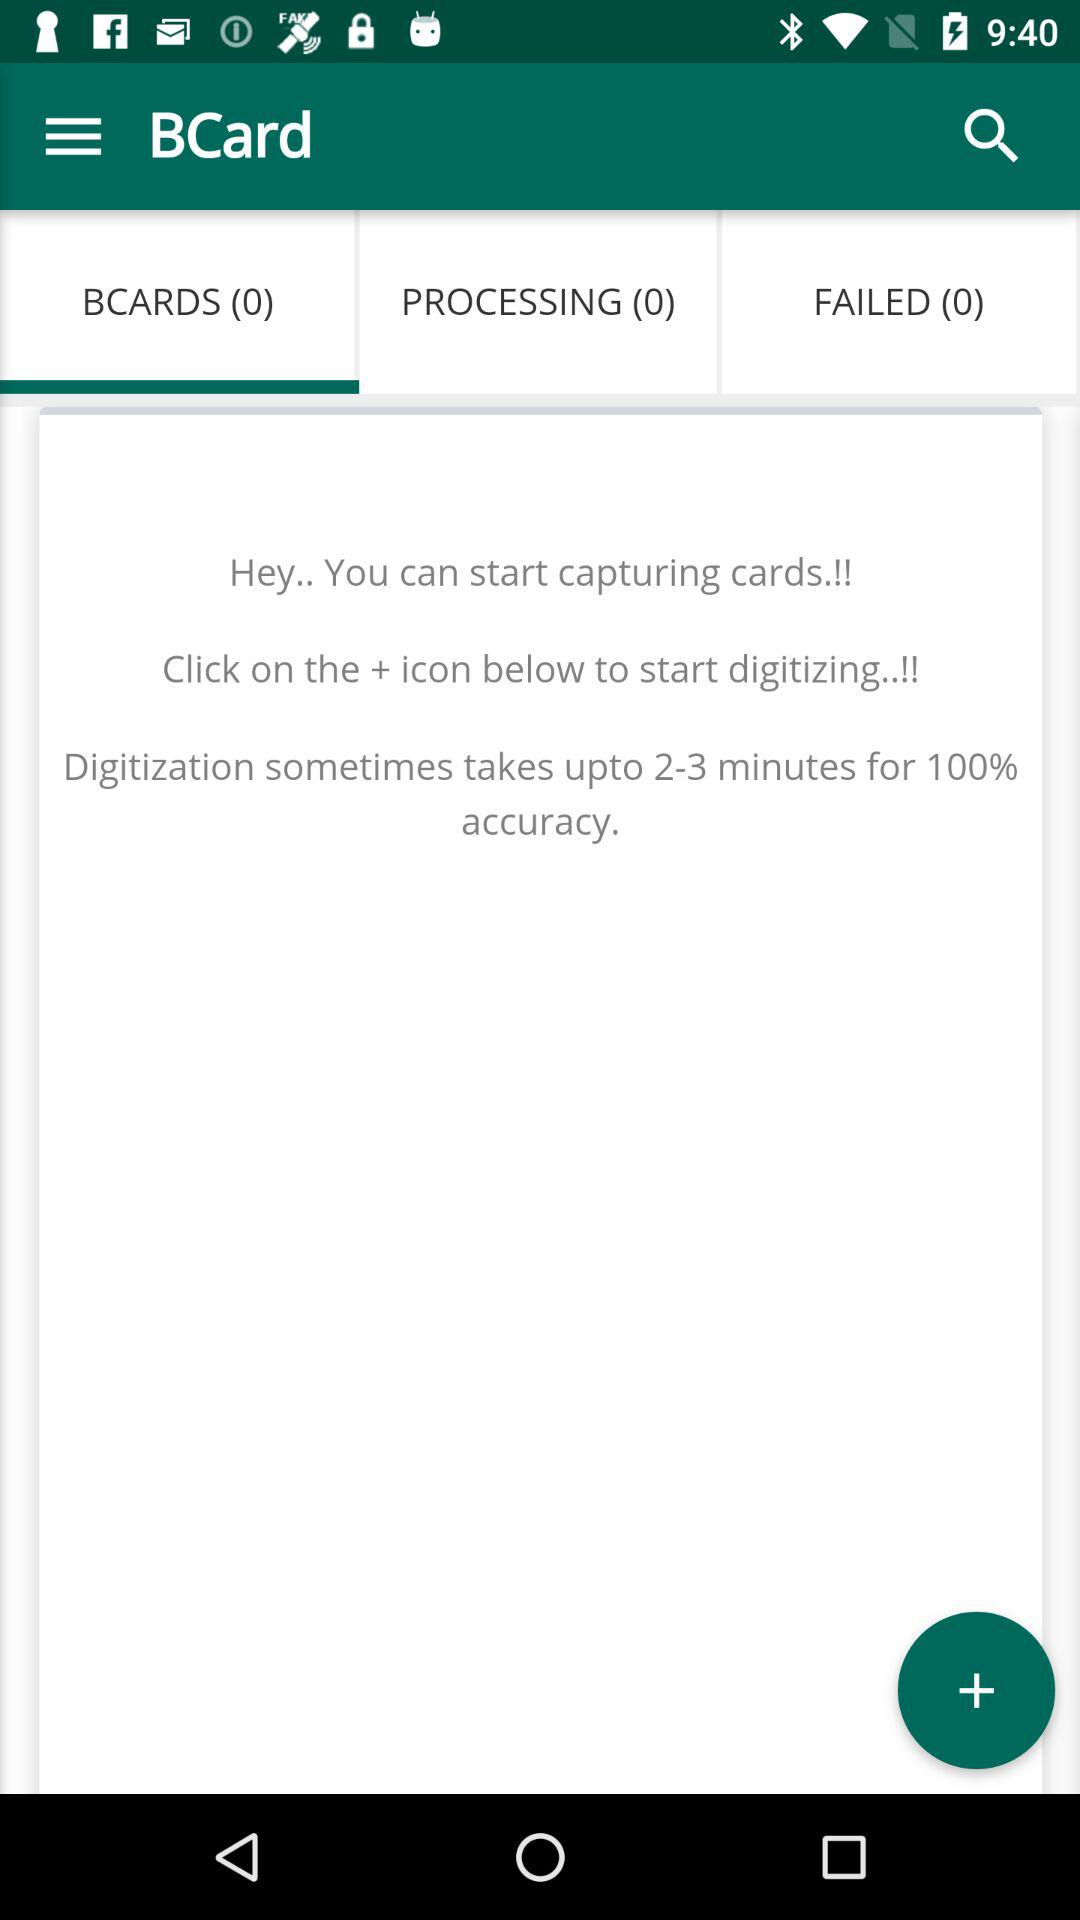Who is this application powered by?
When the provided information is insufficient, respond with <no answer>. <no answer> 